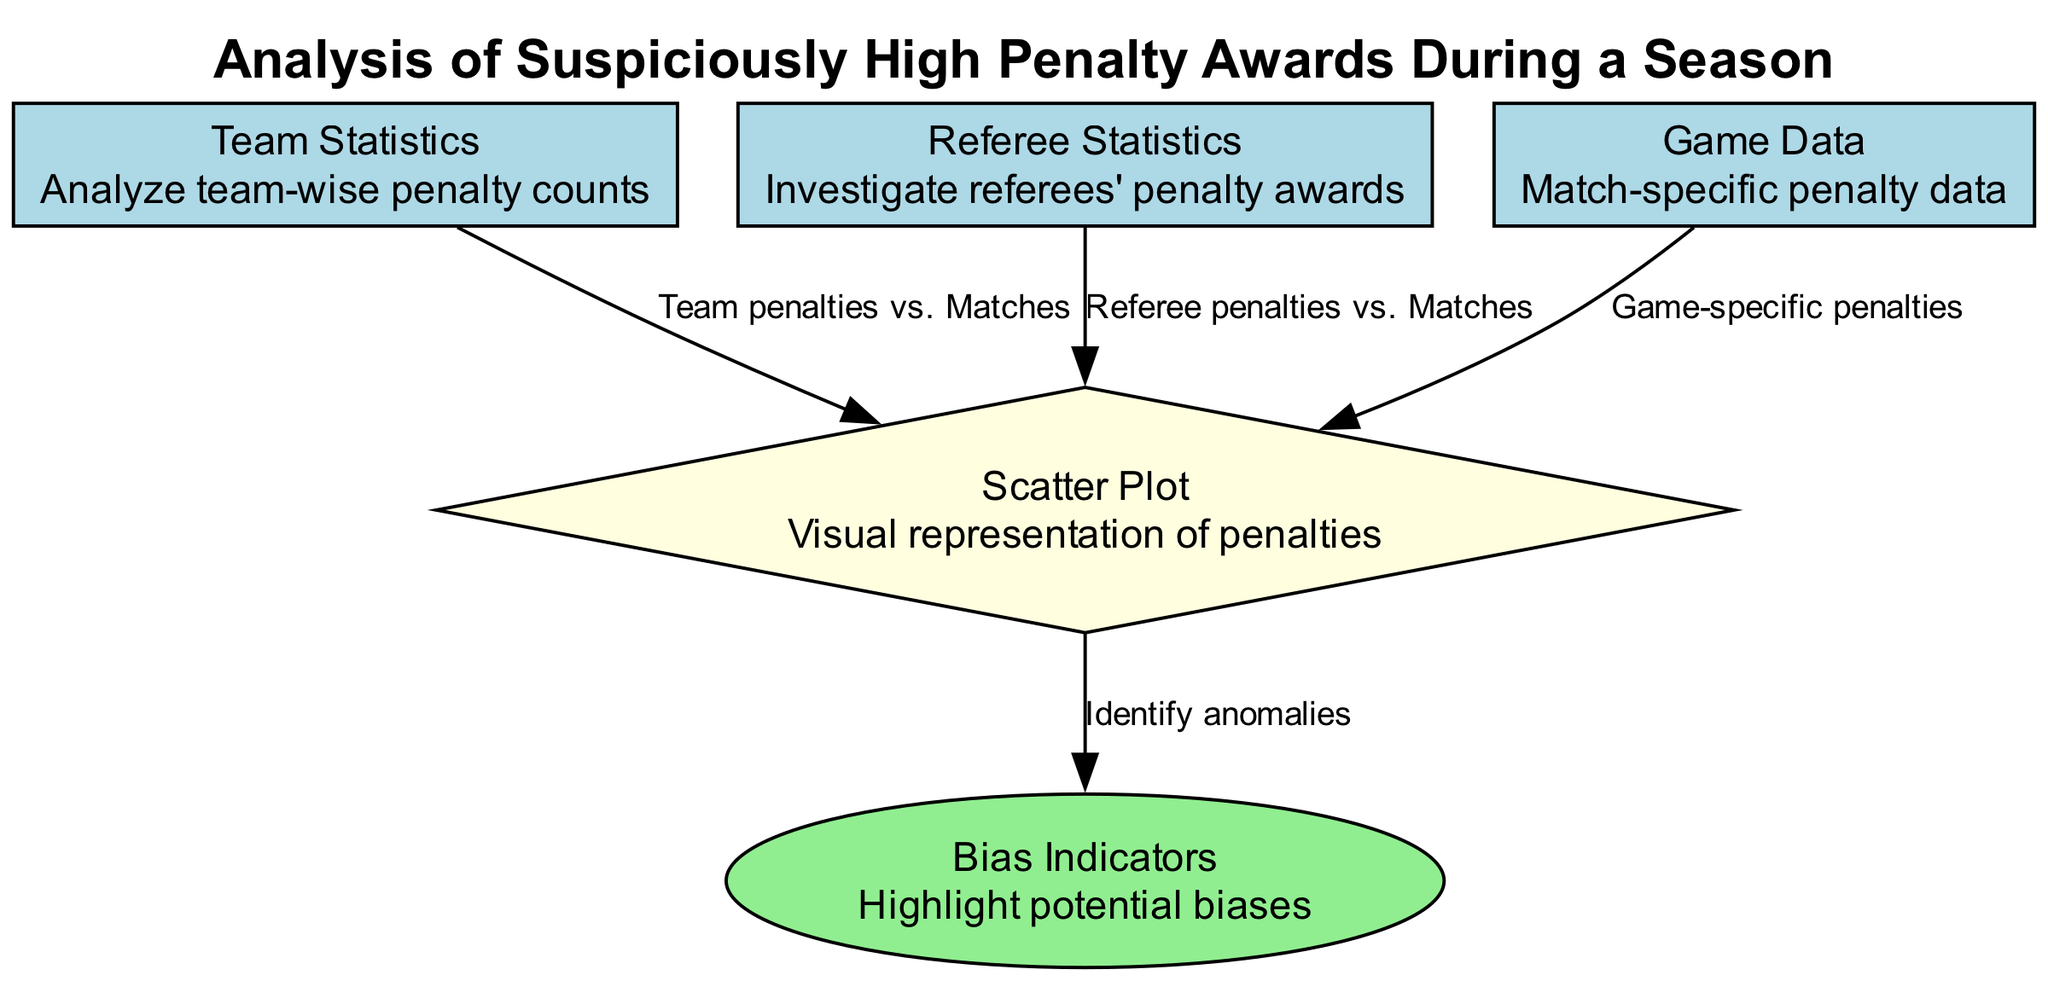What is the main focus of the analysis? The title of the diagram states, "Analysis of Suspiciously High Penalty Awards During a Season," indicating that the central theme is an analysis related to high penalty awards in football.
Answer: Analysis of Suspiciously High Penalty Awards During a Season How many main nodes are there in the diagram? The diagram features five main nodes: Team Statistics, Referee Statistics, Game Data, Scatter Plot, and Bias Indicators. Counting these nodes gives us a total of five.
Answer: 5 Which node specifically investigates referees' penalty awards? The diagram lists "Referee Statistics" as one of the nodes, and its description emphasizes investigating the penalty awards made by referees, making it the answer to the question.
Answer: Referee Statistics What does the edge connecting Team Statistics to Scatter Plot represent? The edge labeled "Team penalties vs. Matches" connects Team Statistics to the Scatter Plot, indicating that this edge represents the relationship between the number of team penalties and the number of matches played.
Answer: Team penalties vs. Matches What is the role of the Scatter Plot in this analysis? The Scatter Plot is described as a "Visual representation of penalties," which means its role is to visually depict the data regarding penalty awards and possibly highlight patterns or biases.
Answer: Visual representation of penalties What do Bias Indicators highlight in the diagram? The Bias Indicators node is connected to the Scatter Plot with an edge labeled "Identify anomalies," which suggests that its purpose is to highlight potential anomalies or biases observed in the penalty data visualized in the Scatter Plot.
Answer: Highlight potential biases How does Game Data contribute to the analysis? The Game Data node connects to the Scatter Plot with the edge labeled "Game-specific penalties," showing that it incorporates specific penalty data from individual matches into the overall analysis presented in the Scatter Plot.
Answer: Game-specific penalties Are there any nodes that focus solely on data specific to individual matches? Yes, the node labeled "Game Data" indicates that it focuses on match-specific penalty data, fulfilling the requirement of focusing solely on individual matches.
Answer: Game Data 